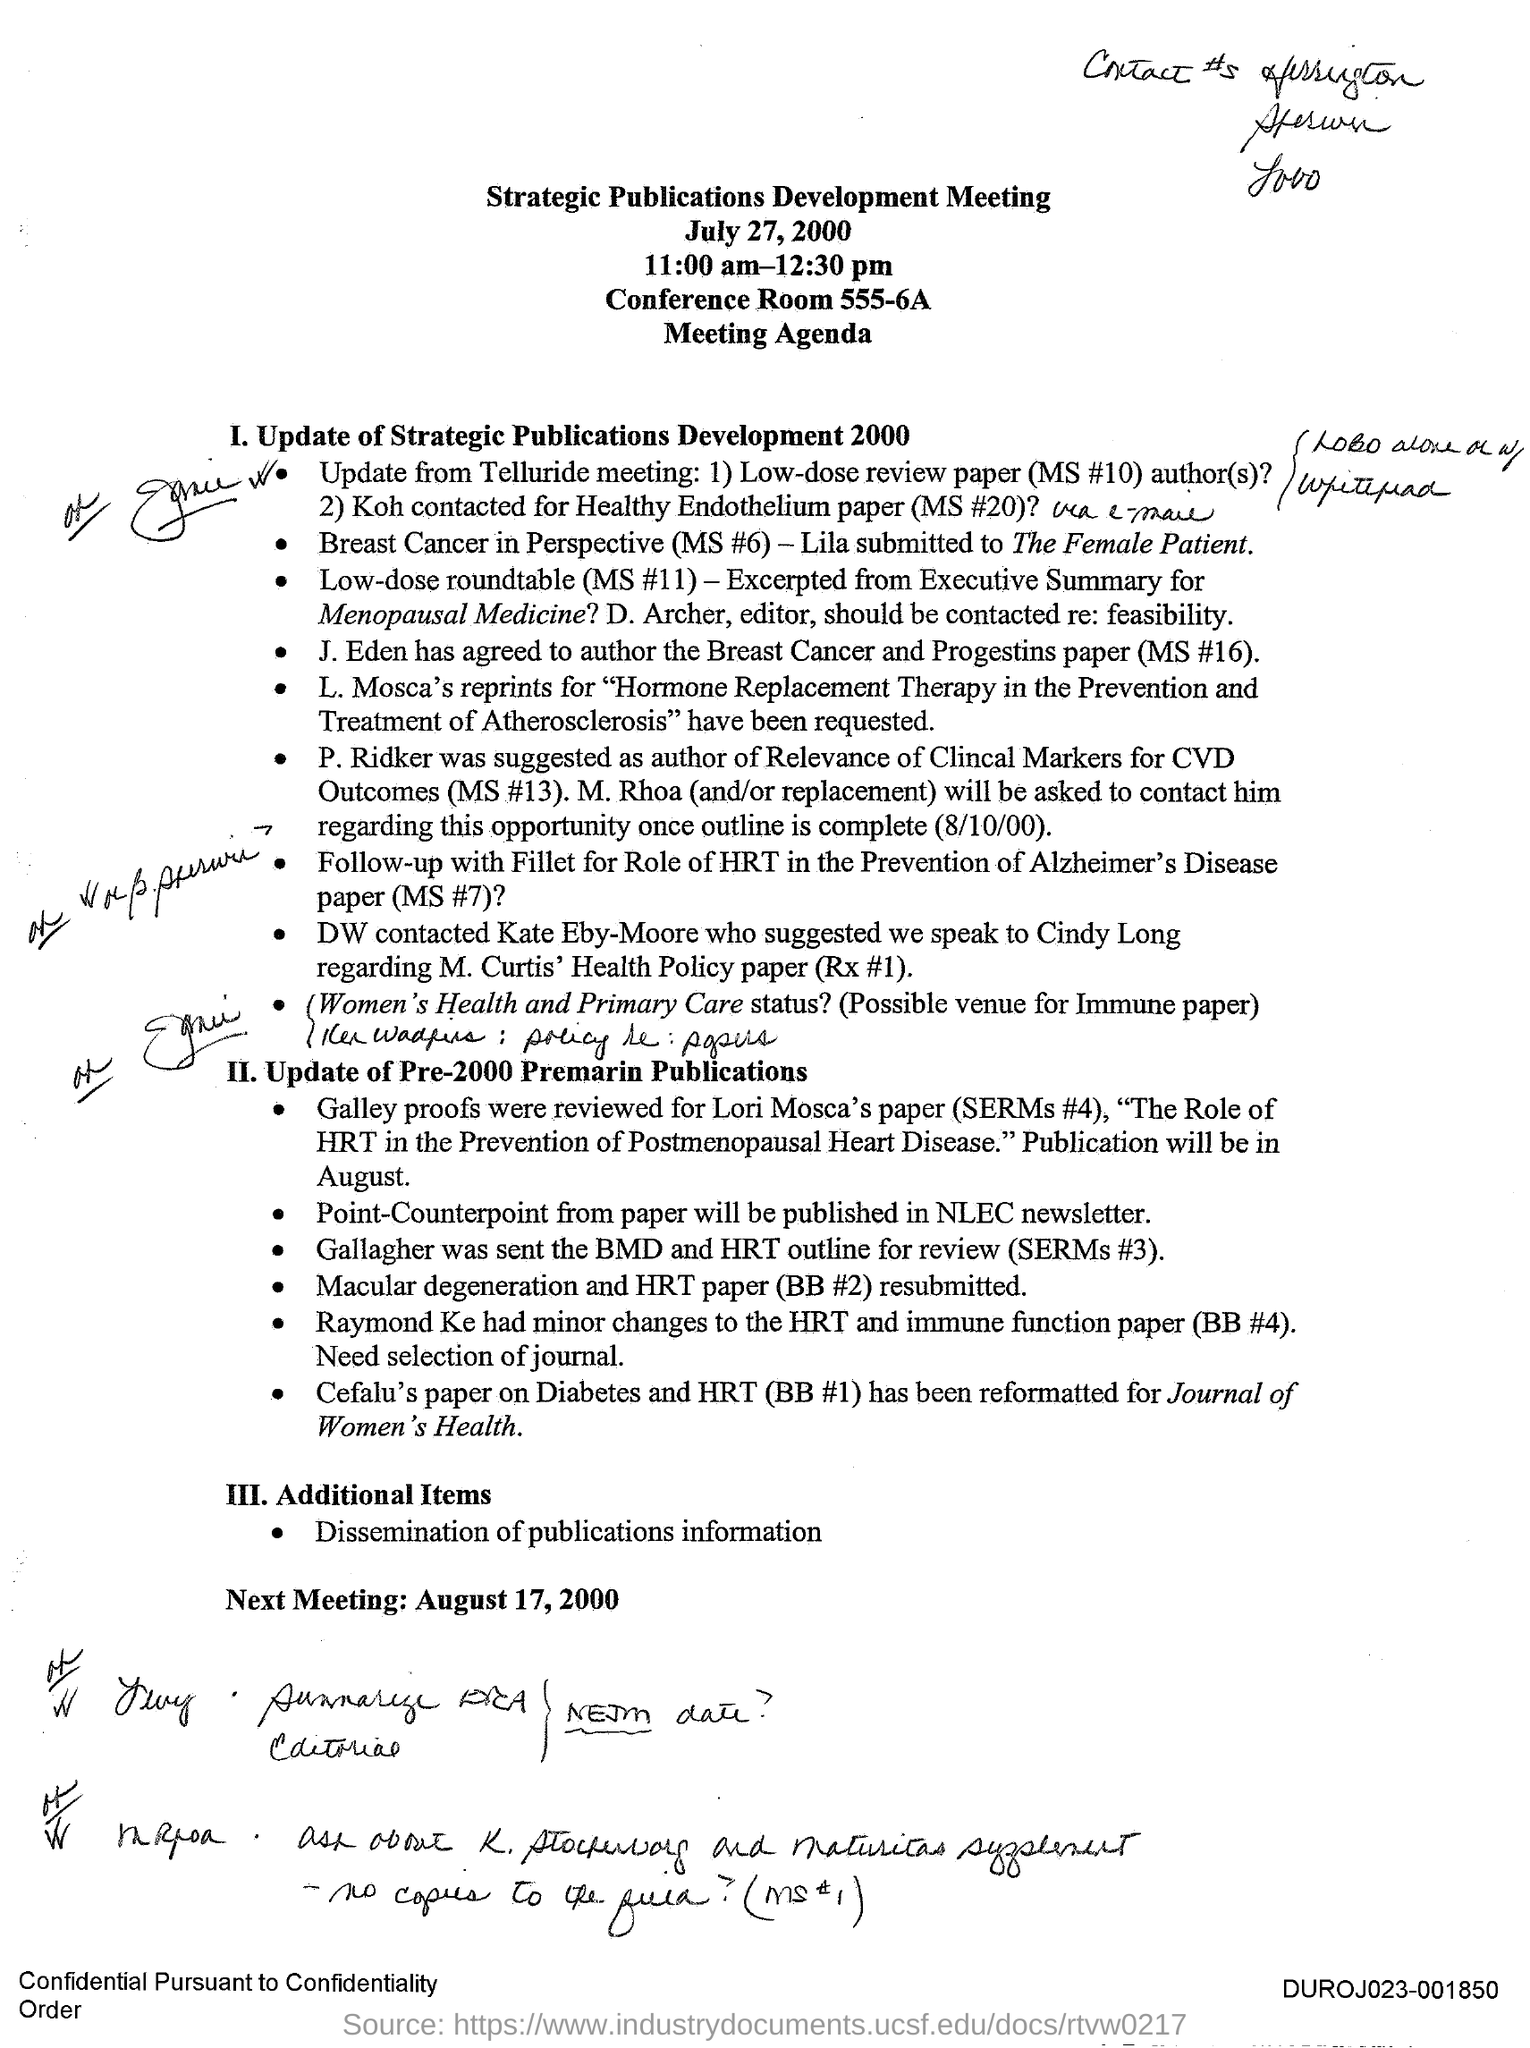Give some essential details in this illustration. The second main agenda is to update the pre-2000 publications related to premarin. The title of the meeting is "Strategic Publication Development Meeting. The strategic publications development meeting is scheduled for July 27, 2000. The meeting occurred between 11:00 am and 12:30 pm. The meeting was held in Conference Room 555-6A. 